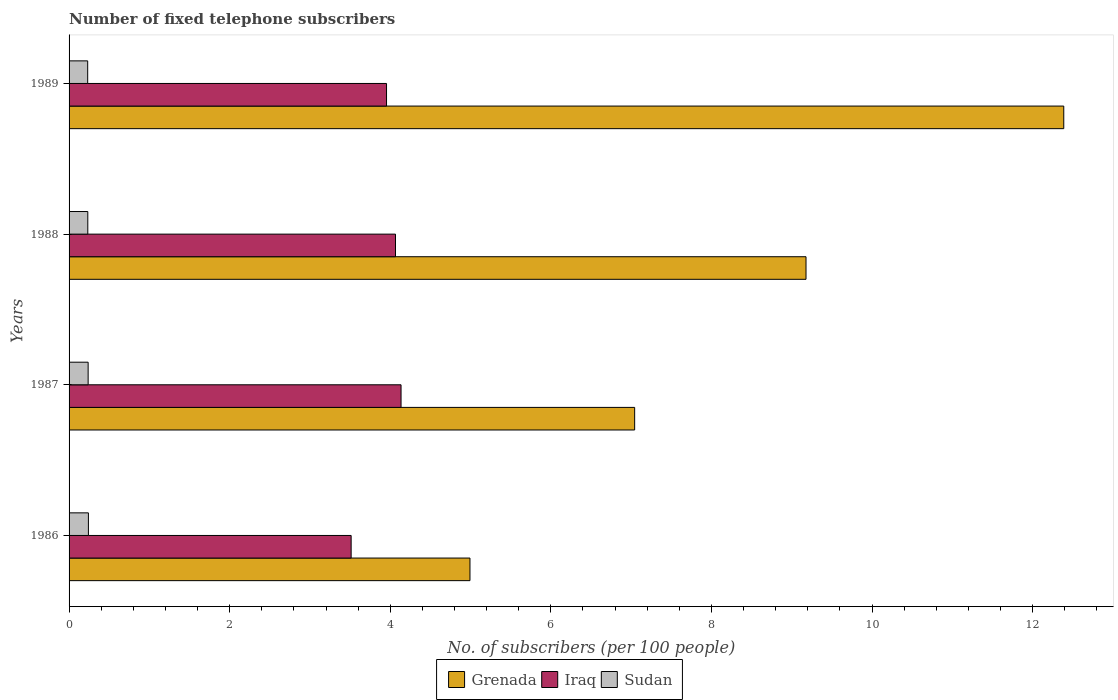How many groups of bars are there?
Offer a terse response. 4. Are the number of bars per tick equal to the number of legend labels?
Your answer should be very brief. Yes. What is the label of the 1st group of bars from the top?
Offer a very short reply. 1989. What is the number of fixed telephone subscribers in Grenada in 1987?
Offer a terse response. 7.04. Across all years, what is the maximum number of fixed telephone subscribers in Iraq?
Keep it short and to the point. 4.13. Across all years, what is the minimum number of fixed telephone subscribers in Sudan?
Your response must be concise. 0.23. In which year was the number of fixed telephone subscribers in Grenada minimum?
Keep it short and to the point. 1986. What is the total number of fixed telephone subscribers in Grenada in the graph?
Offer a terse response. 33.6. What is the difference between the number of fixed telephone subscribers in Sudan in 1988 and that in 1989?
Offer a terse response. 0. What is the difference between the number of fixed telephone subscribers in Iraq in 1987 and the number of fixed telephone subscribers in Grenada in 1989?
Your answer should be compact. -8.25. What is the average number of fixed telephone subscribers in Sudan per year?
Provide a succinct answer. 0.24. In the year 1986, what is the difference between the number of fixed telephone subscribers in Iraq and number of fixed telephone subscribers in Grenada?
Offer a terse response. -1.48. In how many years, is the number of fixed telephone subscribers in Sudan greater than 1.2000000000000002 ?
Provide a short and direct response. 0. What is the ratio of the number of fixed telephone subscribers in Sudan in 1987 to that in 1988?
Offer a terse response. 1.02. Is the difference between the number of fixed telephone subscribers in Iraq in 1986 and 1989 greater than the difference between the number of fixed telephone subscribers in Grenada in 1986 and 1989?
Give a very brief answer. Yes. What is the difference between the highest and the second highest number of fixed telephone subscribers in Iraq?
Keep it short and to the point. 0.07. What is the difference between the highest and the lowest number of fixed telephone subscribers in Iraq?
Keep it short and to the point. 0.62. What does the 2nd bar from the top in 1986 represents?
Your answer should be compact. Iraq. What does the 2nd bar from the bottom in 1986 represents?
Ensure brevity in your answer.  Iraq. Does the graph contain any zero values?
Your response must be concise. No. Does the graph contain grids?
Offer a terse response. No. Where does the legend appear in the graph?
Offer a terse response. Bottom center. How many legend labels are there?
Your answer should be compact. 3. What is the title of the graph?
Provide a succinct answer. Number of fixed telephone subscribers. Does "Sao Tome and Principe" appear as one of the legend labels in the graph?
Make the answer very short. No. What is the label or title of the X-axis?
Offer a very short reply. No. of subscribers (per 100 people). What is the label or title of the Y-axis?
Ensure brevity in your answer.  Years. What is the No. of subscribers (per 100 people) in Grenada in 1986?
Your answer should be compact. 4.99. What is the No. of subscribers (per 100 people) of Iraq in 1986?
Give a very brief answer. 3.51. What is the No. of subscribers (per 100 people) in Sudan in 1986?
Ensure brevity in your answer.  0.24. What is the No. of subscribers (per 100 people) of Grenada in 1987?
Give a very brief answer. 7.04. What is the No. of subscribers (per 100 people) of Iraq in 1987?
Provide a short and direct response. 4.13. What is the No. of subscribers (per 100 people) of Sudan in 1987?
Give a very brief answer. 0.24. What is the No. of subscribers (per 100 people) in Grenada in 1988?
Ensure brevity in your answer.  9.18. What is the No. of subscribers (per 100 people) in Iraq in 1988?
Offer a very short reply. 4.07. What is the No. of subscribers (per 100 people) of Sudan in 1988?
Ensure brevity in your answer.  0.23. What is the No. of subscribers (per 100 people) in Grenada in 1989?
Your answer should be very brief. 12.39. What is the No. of subscribers (per 100 people) of Iraq in 1989?
Your answer should be very brief. 3.95. What is the No. of subscribers (per 100 people) of Sudan in 1989?
Give a very brief answer. 0.23. Across all years, what is the maximum No. of subscribers (per 100 people) in Grenada?
Ensure brevity in your answer.  12.39. Across all years, what is the maximum No. of subscribers (per 100 people) of Iraq?
Offer a very short reply. 4.13. Across all years, what is the maximum No. of subscribers (per 100 people) in Sudan?
Provide a short and direct response. 0.24. Across all years, what is the minimum No. of subscribers (per 100 people) of Grenada?
Offer a terse response. 4.99. Across all years, what is the minimum No. of subscribers (per 100 people) of Iraq?
Provide a succinct answer. 3.51. Across all years, what is the minimum No. of subscribers (per 100 people) in Sudan?
Offer a very short reply. 0.23. What is the total No. of subscribers (per 100 people) in Grenada in the graph?
Make the answer very short. 33.6. What is the total No. of subscribers (per 100 people) of Iraq in the graph?
Offer a very short reply. 15.67. What is the total No. of subscribers (per 100 people) in Sudan in the graph?
Your response must be concise. 0.94. What is the difference between the No. of subscribers (per 100 people) in Grenada in 1986 and that in 1987?
Give a very brief answer. -2.05. What is the difference between the No. of subscribers (per 100 people) of Iraq in 1986 and that in 1987?
Make the answer very short. -0.62. What is the difference between the No. of subscribers (per 100 people) in Sudan in 1986 and that in 1987?
Your answer should be compact. 0. What is the difference between the No. of subscribers (per 100 people) of Grenada in 1986 and that in 1988?
Make the answer very short. -4.19. What is the difference between the No. of subscribers (per 100 people) of Iraq in 1986 and that in 1988?
Keep it short and to the point. -0.55. What is the difference between the No. of subscribers (per 100 people) in Sudan in 1986 and that in 1988?
Ensure brevity in your answer.  0.01. What is the difference between the No. of subscribers (per 100 people) of Grenada in 1986 and that in 1989?
Your answer should be very brief. -7.39. What is the difference between the No. of subscribers (per 100 people) in Iraq in 1986 and that in 1989?
Your response must be concise. -0.44. What is the difference between the No. of subscribers (per 100 people) in Sudan in 1986 and that in 1989?
Your answer should be very brief. 0.01. What is the difference between the No. of subscribers (per 100 people) of Grenada in 1987 and that in 1988?
Give a very brief answer. -2.13. What is the difference between the No. of subscribers (per 100 people) of Iraq in 1987 and that in 1988?
Provide a short and direct response. 0.07. What is the difference between the No. of subscribers (per 100 people) in Sudan in 1987 and that in 1988?
Provide a short and direct response. 0. What is the difference between the No. of subscribers (per 100 people) of Grenada in 1987 and that in 1989?
Provide a succinct answer. -5.34. What is the difference between the No. of subscribers (per 100 people) in Iraq in 1987 and that in 1989?
Offer a terse response. 0.18. What is the difference between the No. of subscribers (per 100 people) of Sudan in 1987 and that in 1989?
Give a very brief answer. 0.01. What is the difference between the No. of subscribers (per 100 people) of Grenada in 1988 and that in 1989?
Ensure brevity in your answer.  -3.21. What is the difference between the No. of subscribers (per 100 people) in Iraq in 1988 and that in 1989?
Keep it short and to the point. 0.11. What is the difference between the No. of subscribers (per 100 people) of Sudan in 1988 and that in 1989?
Make the answer very short. 0. What is the difference between the No. of subscribers (per 100 people) of Grenada in 1986 and the No. of subscribers (per 100 people) of Iraq in 1987?
Your answer should be compact. 0.86. What is the difference between the No. of subscribers (per 100 people) in Grenada in 1986 and the No. of subscribers (per 100 people) in Sudan in 1987?
Give a very brief answer. 4.76. What is the difference between the No. of subscribers (per 100 people) in Iraq in 1986 and the No. of subscribers (per 100 people) in Sudan in 1987?
Provide a succinct answer. 3.28. What is the difference between the No. of subscribers (per 100 people) in Grenada in 1986 and the No. of subscribers (per 100 people) in Iraq in 1988?
Provide a succinct answer. 0.93. What is the difference between the No. of subscribers (per 100 people) of Grenada in 1986 and the No. of subscribers (per 100 people) of Sudan in 1988?
Give a very brief answer. 4.76. What is the difference between the No. of subscribers (per 100 people) of Iraq in 1986 and the No. of subscribers (per 100 people) of Sudan in 1988?
Make the answer very short. 3.28. What is the difference between the No. of subscribers (per 100 people) of Grenada in 1986 and the No. of subscribers (per 100 people) of Iraq in 1989?
Your response must be concise. 1.04. What is the difference between the No. of subscribers (per 100 people) of Grenada in 1986 and the No. of subscribers (per 100 people) of Sudan in 1989?
Offer a very short reply. 4.76. What is the difference between the No. of subscribers (per 100 people) of Iraq in 1986 and the No. of subscribers (per 100 people) of Sudan in 1989?
Your response must be concise. 3.28. What is the difference between the No. of subscribers (per 100 people) of Grenada in 1987 and the No. of subscribers (per 100 people) of Iraq in 1988?
Keep it short and to the point. 2.98. What is the difference between the No. of subscribers (per 100 people) of Grenada in 1987 and the No. of subscribers (per 100 people) of Sudan in 1988?
Your answer should be very brief. 6.81. What is the difference between the No. of subscribers (per 100 people) in Iraq in 1987 and the No. of subscribers (per 100 people) in Sudan in 1988?
Keep it short and to the point. 3.9. What is the difference between the No. of subscribers (per 100 people) of Grenada in 1987 and the No. of subscribers (per 100 people) of Iraq in 1989?
Your response must be concise. 3.09. What is the difference between the No. of subscribers (per 100 people) in Grenada in 1987 and the No. of subscribers (per 100 people) in Sudan in 1989?
Your response must be concise. 6.81. What is the difference between the No. of subscribers (per 100 people) in Iraq in 1987 and the No. of subscribers (per 100 people) in Sudan in 1989?
Your response must be concise. 3.9. What is the difference between the No. of subscribers (per 100 people) in Grenada in 1988 and the No. of subscribers (per 100 people) in Iraq in 1989?
Offer a terse response. 5.22. What is the difference between the No. of subscribers (per 100 people) in Grenada in 1988 and the No. of subscribers (per 100 people) in Sudan in 1989?
Give a very brief answer. 8.95. What is the difference between the No. of subscribers (per 100 people) of Iraq in 1988 and the No. of subscribers (per 100 people) of Sudan in 1989?
Give a very brief answer. 3.83. What is the average No. of subscribers (per 100 people) in Grenada per year?
Your answer should be compact. 8.4. What is the average No. of subscribers (per 100 people) of Iraq per year?
Your answer should be very brief. 3.92. What is the average No. of subscribers (per 100 people) in Sudan per year?
Offer a terse response. 0.24. In the year 1986, what is the difference between the No. of subscribers (per 100 people) in Grenada and No. of subscribers (per 100 people) in Iraq?
Give a very brief answer. 1.48. In the year 1986, what is the difference between the No. of subscribers (per 100 people) of Grenada and No. of subscribers (per 100 people) of Sudan?
Your answer should be compact. 4.75. In the year 1986, what is the difference between the No. of subscribers (per 100 people) of Iraq and No. of subscribers (per 100 people) of Sudan?
Give a very brief answer. 3.27. In the year 1987, what is the difference between the No. of subscribers (per 100 people) in Grenada and No. of subscribers (per 100 people) in Iraq?
Keep it short and to the point. 2.91. In the year 1987, what is the difference between the No. of subscribers (per 100 people) of Grenada and No. of subscribers (per 100 people) of Sudan?
Offer a terse response. 6.81. In the year 1987, what is the difference between the No. of subscribers (per 100 people) in Iraq and No. of subscribers (per 100 people) in Sudan?
Ensure brevity in your answer.  3.9. In the year 1988, what is the difference between the No. of subscribers (per 100 people) in Grenada and No. of subscribers (per 100 people) in Iraq?
Your answer should be very brief. 5.11. In the year 1988, what is the difference between the No. of subscribers (per 100 people) of Grenada and No. of subscribers (per 100 people) of Sudan?
Provide a short and direct response. 8.94. In the year 1988, what is the difference between the No. of subscribers (per 100 people) of Iraq and No. of subscribers (per 100 people) of Sudan?
Offer a very short reply. 3.83. In the year 1989, what is the difference between the No. of subscribers (per 100 people) in Grenada and No. of subscribers (per 100 people) in Iraq?
Offer a very short reply. 8.43. In the year 1989, what is the difference between the No. of subscribers (per 100 people) of Grenada and No. of subscribers (per 100 people) of Sudan?
Your response must be concise. 12.16. In the year 1989, what is the difference between the No. of subscribers (per 100 people) in Iraq and No. of subscribers (per 100 people) in Sudan?
Provide a succinct answer. 3.72. What is the ratio of the No. of subscribers (per 100 people) in Grenada in 1986 to that in 1987?
Ensure brevity in your answer.  0.71. What is the ratio of the No. of subscribers (per 100 people) in Iraq in 1986 to that in 1987?
Your response must be concise. 0.85. What is the ratio of the No. of subscribers (per 100 people) of Sudan in 1986 to that in 1987?
Provide a succinct answer. 1.01. What is the ratio of the No. of subscribers (per 100 people) in Grenada in 1986 to that in 1988?
Provide a short and direct response. 0.54. What is the ratio of the No. of subscribers (per 100 people) in Iraq in 1986 to that in 1988?
Your response must be concise. 0.86. What is the ratio of the No. of subscribers (per 100 people) in Sudan in 1986 to that in 1988?
Your answer should be very brief. 1.03. What is the ratio of the No. of subscribers (per 100 people) of Grenada in 1986 to that in 1989?
Your answer should be compact. 0.4. What is the ratio of the No. of subscribers (per 100 people) in Iraq in 1986 to that in 1989?
Ensure brevity in your answer.  0.89. What is the ratio of the No. of subscribers (per 100 people) of Sudan in 1986 to that in 1989?
Your answer should be compact. 1.04. What is the ratio of the No. of subscribers (per 100 people) in Grenada in 1987 to that in 1988?
Make the answer very short. 0.77. What is the ratio of the No. of subscribers (per 100 people) of Sudan in 1987 to that in 1988?
Ensure brevity in your answer.  1.02. What is the ratio of the No. of subscribers (per 100 people) of Grenada in 1987 to that in 1989?
Offer a terse response. 0.57. What is the ratio of the No. of subscribers (per 100 people) of Iraq in 1987 to that in 1989?
Keep it short and to the point. 1.05. What is the ratio of the No. of subscribers (per 100 people) in Sudan in 1987 to that in 1989?
Give a very brief answer. 1.02. What is the ratio of the No. of subscribers (per 100 people) of Grenada in 1988 to that in 1989?
Offer a very short reply. 0.74. What is the ratio of the No. of subscribers (per 100 people) of Iraq in 1988 to that in 1989?
Your answer should be very brief. 1.03. What is the difference between the highest and the second highest No. of subscribers (per 100 people) of Grenada?
Ensure brevity in your answer.  3.21. What is the difference between the highest and the second highest No. of subscribers (per 100 people) in Iraq?
Give a very brief answer. 0.07. What is the difference between the highest and the second highest No. of subscribers (per 100 people) of Sudan?
Keep it short and to the point. 0. What is the difference between the highest and the lowest No. of subscribers (per 100 people) of Grenada?
Give a very brief answer. 7.39. What is the difference between the highest and the lowest No. of subscribers (per 100 people) of Iraq?
Make the answer very short. 0.62. What is the difference between the highest and the lowest No. of subscribers (per 100 people) in Sudan?
Your response must be concise. 0.01. 